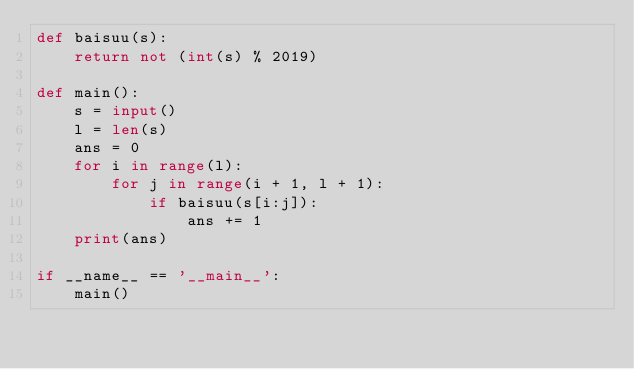<code> <loc_0><loc_0><loc_500><loc_500><_Python_>def baisuu(s):
    return not (int(s) % 2019)

def main():
    s = input()
    l = len(s)
    ans = 0
    for i in range(l):
        for j in range(i + 1, l + 1):
            if baisuu(s[i:j]):
                ans += 1
    print(ans)

if __name__ == '__main__':
    main()</code> 